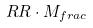<formula> <loc_0><loc_0><loc_500><loc_500>R R \cdot M _ { f r a c }</formula> 